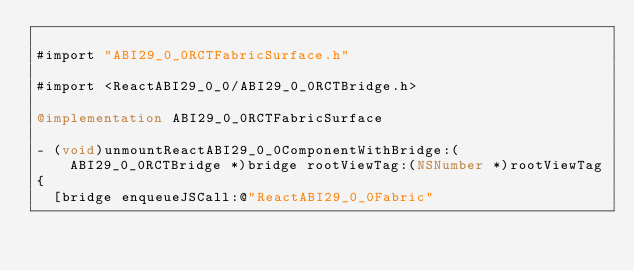Convert code to text. <code><loc_0><loc_0><loc_500><loc_500><_ObjectiveC_>
#import "ABI29_0_0RCTFabricSurface.h"

#import <ReactABI29_0_0/ABI29_0_0RCTBridge.h>

@implementation ABI29_0_0RCTFabricSurface

- (void)unmountReactABI29_0_0ComponentWithBridge:(ABI29_0_0RCTBridge *)bridge rootViewTag:(NSNumber *)rootViewTag
{
  [bridge enqueueJSCall:@"ReactABI29_0_0Fabric"</code> 